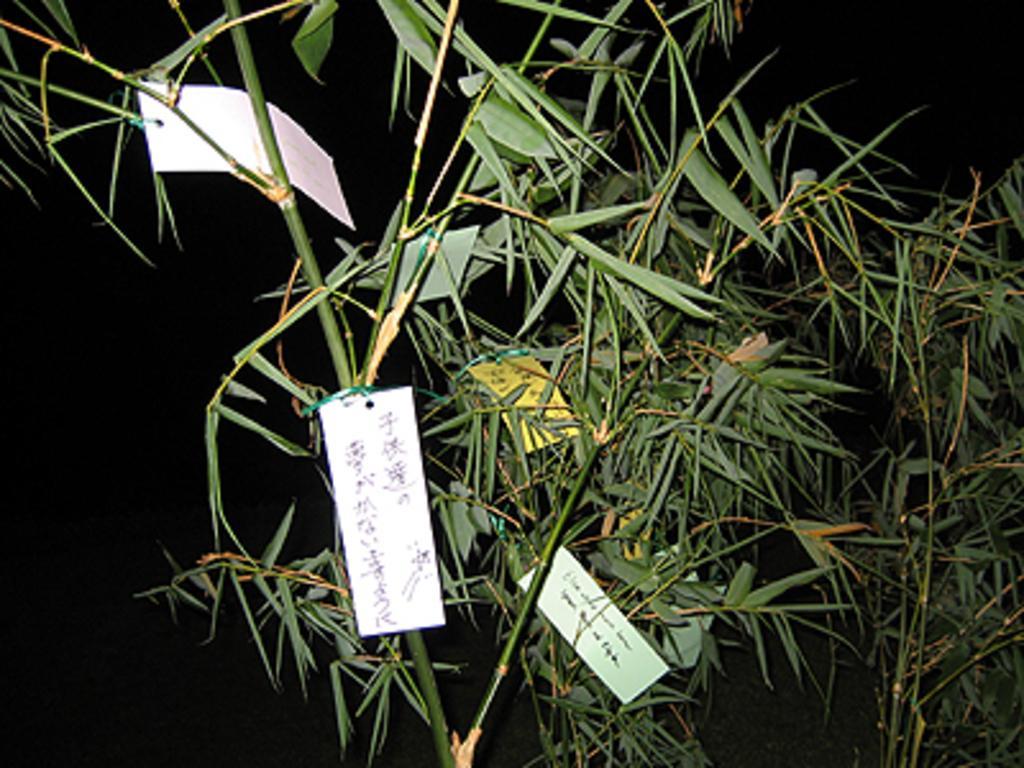Could you give a brief overview of what you see in this image? In this picture we can see few cards on the plant. Background is black in color. 